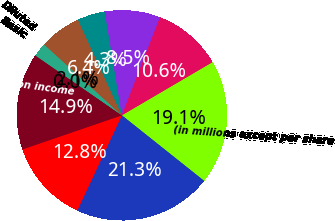<chart> <loc_0><loc_0><loc_500><loc_500><pie_chart><fcel>(in millions except per share<fcel>Revenue<fcel>Operating profit<fcel>Provision for taxes on income<fcel>Basic<fcel>Diluted<fcel>Return on average equity 6<fcel>Income from continuing<fcel>Net income (loss) from<fcel>Working capital<nl><fcel>19.15%<fcel>21.27%<fcel>12.77%<fcel>14.89%<fcel>0.0%<fcel>2.13%<fcel>6.38%<fcel>4.26%<fcel>8.51%<fcel>10.64%<nl></chart> 